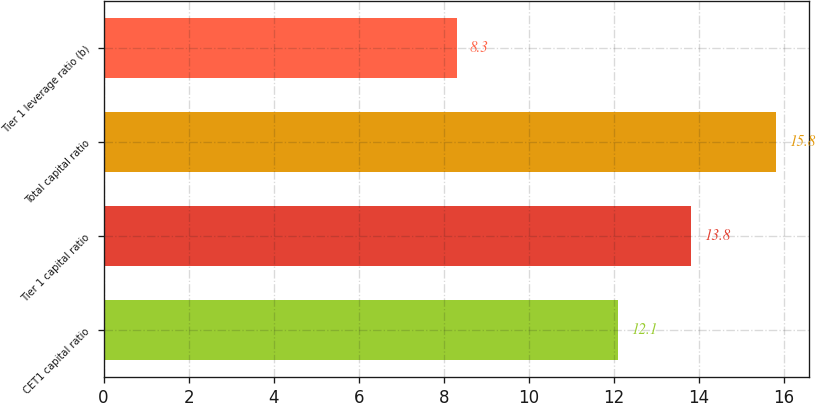<chart> <loc_0><loc_0><loc_500><loc_500><bar_chart><fcel>CET1 capital ratio<fcel>Tier 1 capital ratio<fcel>Total capital ratio<fcel>Tier 1 leverage ratio (b)<nl><fcel>12.1<fcel>13.8<fcel>15.8<fcel>8.3<nl></chart> 